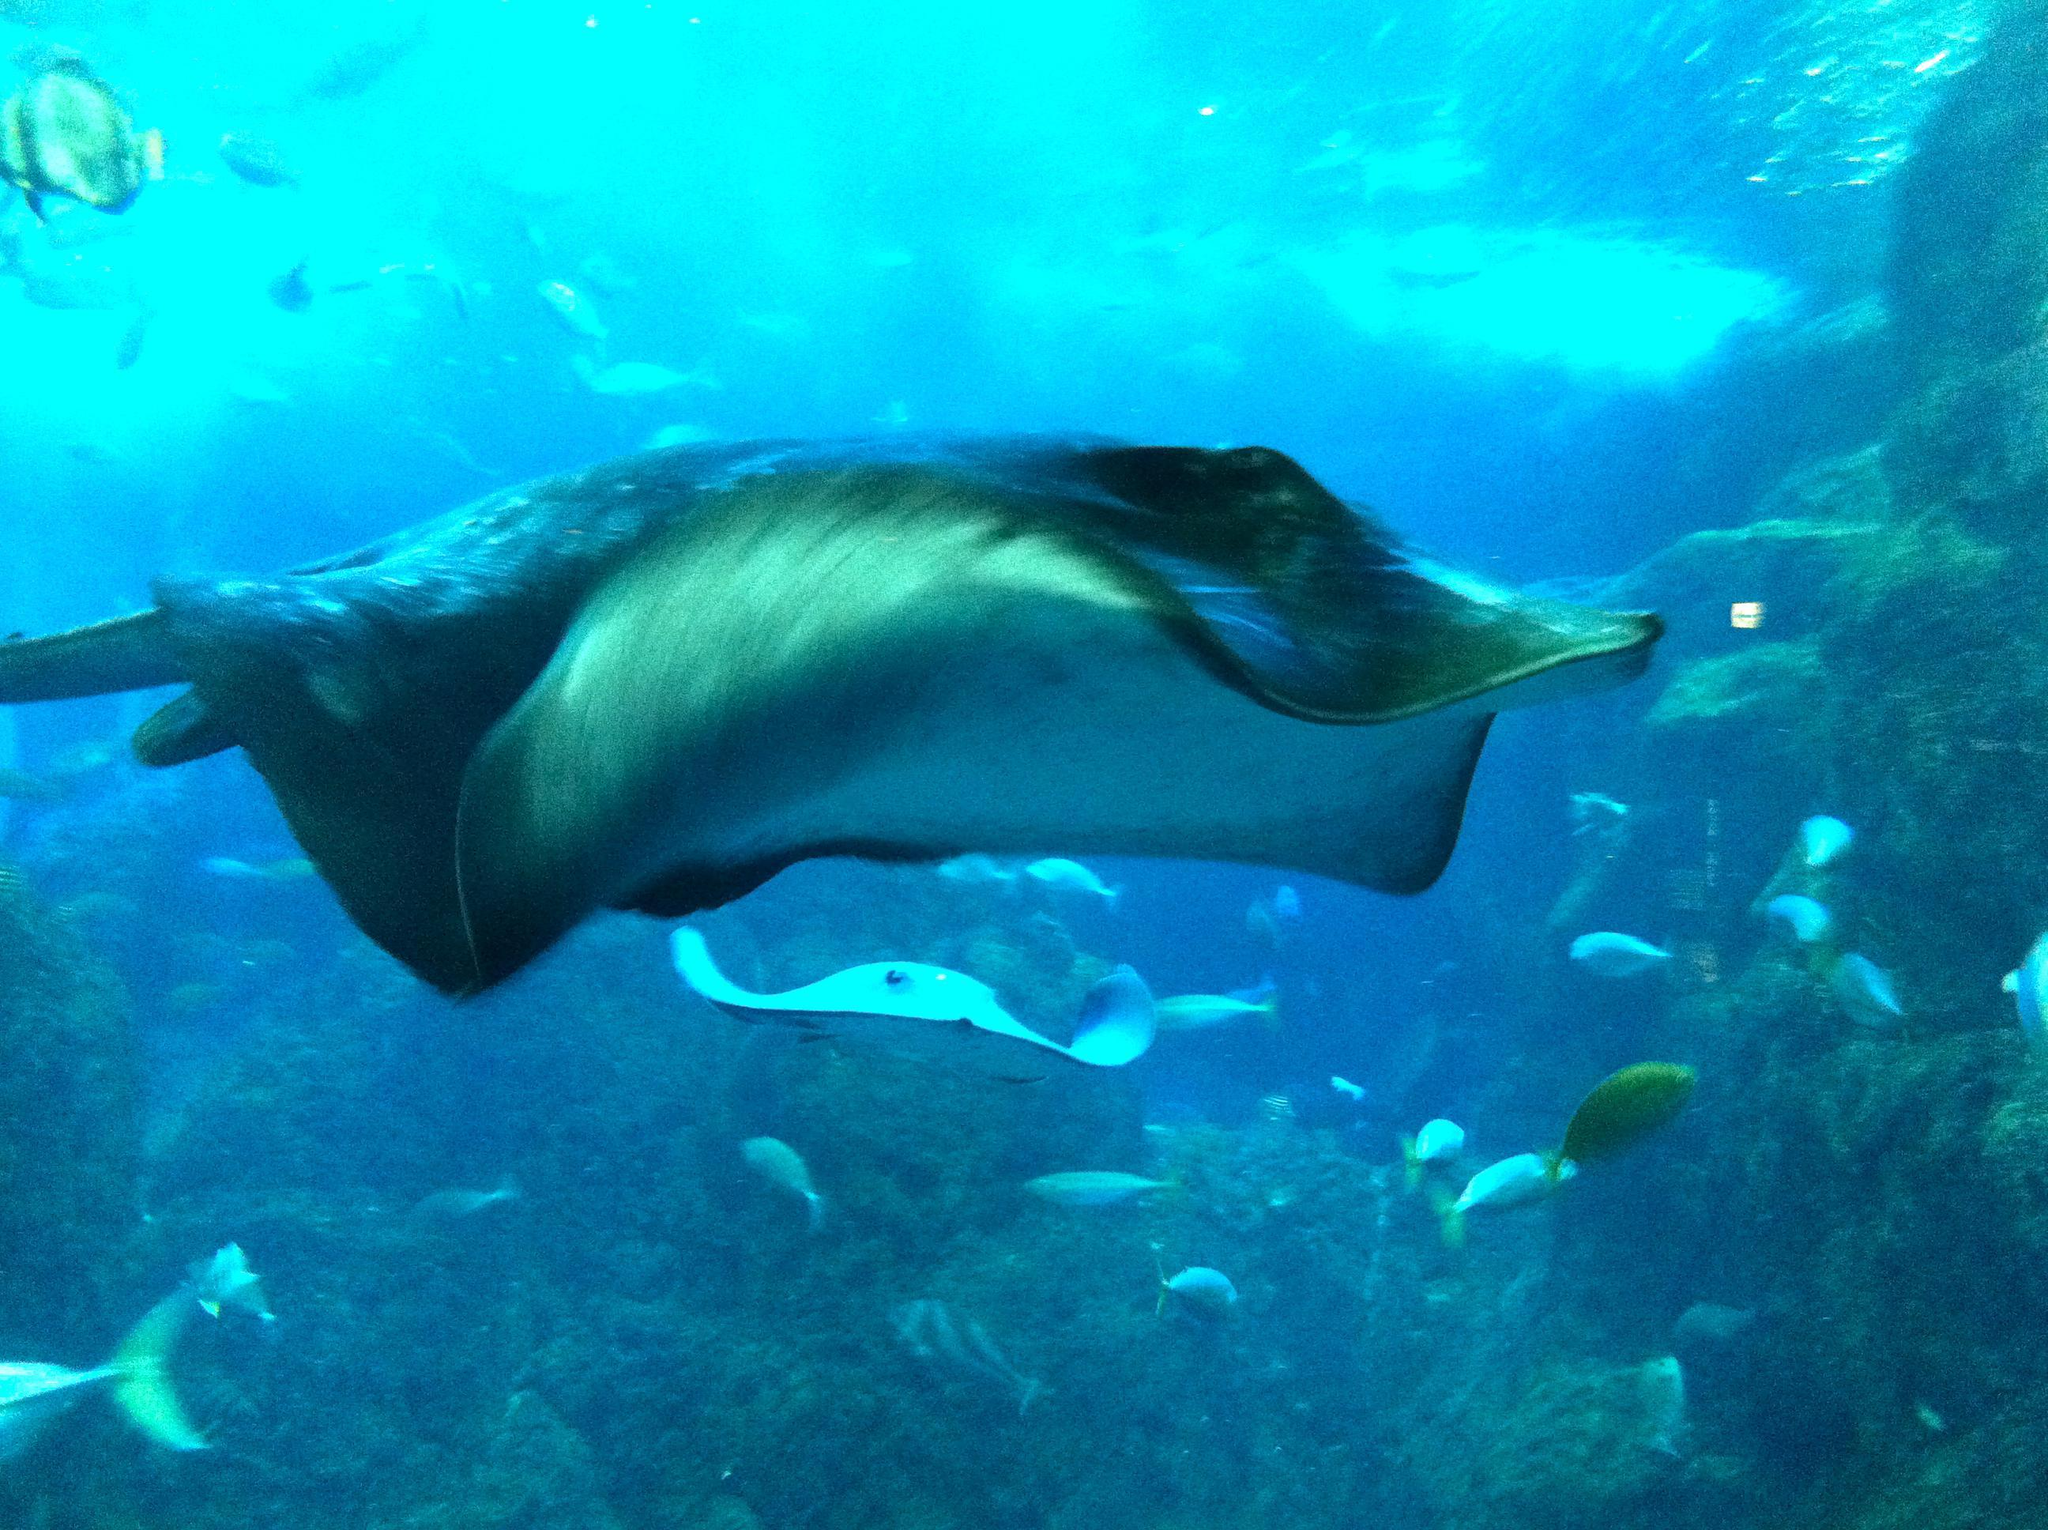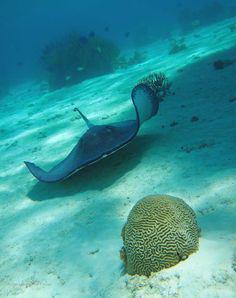The first image is the image on the left, the second image is the image on the right. Assess this claim about the two images: "There is a manta ray.". Correct or not? Answer yes or no. No. 